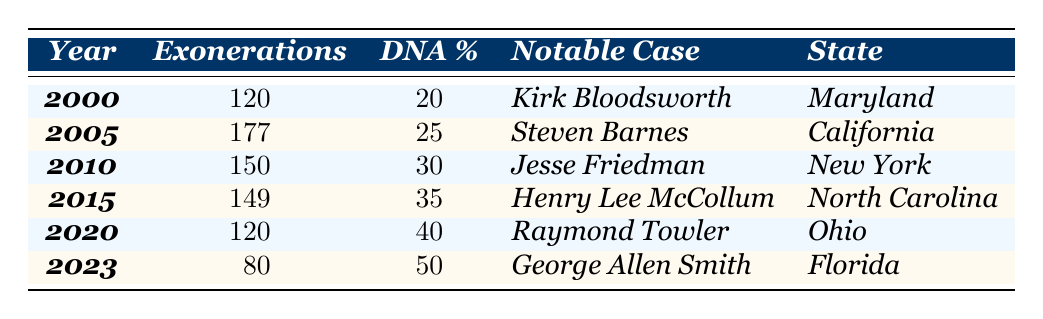What was the year with the highest percentage of exonerations due to DNA evidence? From the table, the year with the highest percentage is 2023, where 50% of exonerations were due to DNA evidence.
Answer: 2023 How many exonerations were reported in 2010? The table shows that there were 150 exonerations reported in 2010.
Answer: 150 Which notable case was associated with the most exonerations in the year 2005? According to the table, the notable case associated with the most exonerations in 2005 is Steven Barnes.
Answer: Steven Barnes What is the total number of exonerations from 2000 to 2023? Summing the exonerations from each year gives (120 + 177 + 150 + 149 + 120 + 80) = 796.
Answer: 796 Is it true that the majority of exonerations in 2020 were due to DNA evidence? In 2020, 40% of the exonerations were due to DNA evidence, which does not constitute a majority (greater than 50%).
Answer: No What was the increase in the percentage of exonerations due to DNA evidence from 2000 to 2023? The percentage increased from 20% in 2000 to 50% in 2023, giving an increase of (50 - 20) = 30%.
Answer: 30% How many more exonerations were there in 2005 than in 2023? The table indicates 177 exonerations in 2005 and 80 in 2023, hence the difference is (177 - 80) = 97 more exonerations in 2005.
Answer: 97 Which state had the notable case of Jesse Friedman? The table specifies that Jesse Friedman was associated with the state of New York.
Answer: New York Calculate the average percentage of exonerations due to DNA evidence from 2000 to 2023. The percentages are 20%, 25%, 30%, 35%, 40%, and 50%. The sum is (20 + 25 + 30 + 35 + 40 + 50) = 200, and the average is 200/6 ≈ 33.33%.
Answer: Approximately 33.33% In what year did North Carolina report the least number of exonerations due to DNA evidence? Looking at the table, North Carolina reported 149 exonerations in 2015, indicating that other years had higher or similar numbers.
Answer: 2015 